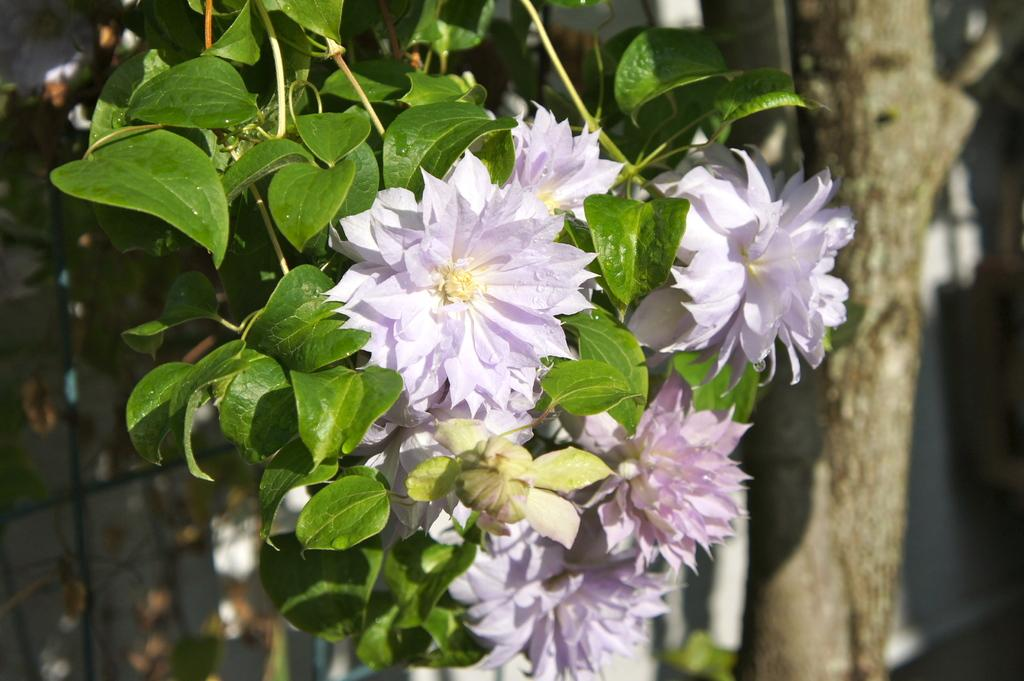What is the main subject of the image? The main subject of the image is flowers and leaves in the center. Can you describe the tree trunk in the image? There is a tree trunk on the right side of the image. How many toy jellyfish can be seen in the field in the image? There are no toys or jellyfish present in the image, and there is no field mentioned in the facts. 